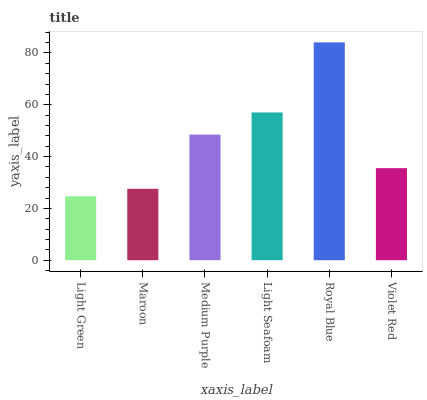Is Light Green the minimum?
Answer yes or no. Yes. Is Royal Blue the maximum?
Answer yes or no. Yes. Is Maroon the minimum?
Answer yes or no. No. Is Maroon the maximum?
Answer yes or no. No. Is Maroon greater than Light Green?
Answer yes or no. Yes. Is Light Green less than Maroon?
Answer yes or no. Yes. Is Light Green greater than Maroon?
Answer yes or no. No. Is Maroon less than Light Green?
Answer yes or no. No. Is Medium Purple the high median?
Answer yes or no. Yes. Is Violet Red the low median?
Answer yes or no. Yes. Is Maroon the high median?
Answer yes or no. No. Is Maroon the low median?
Answer yes or no. No. 